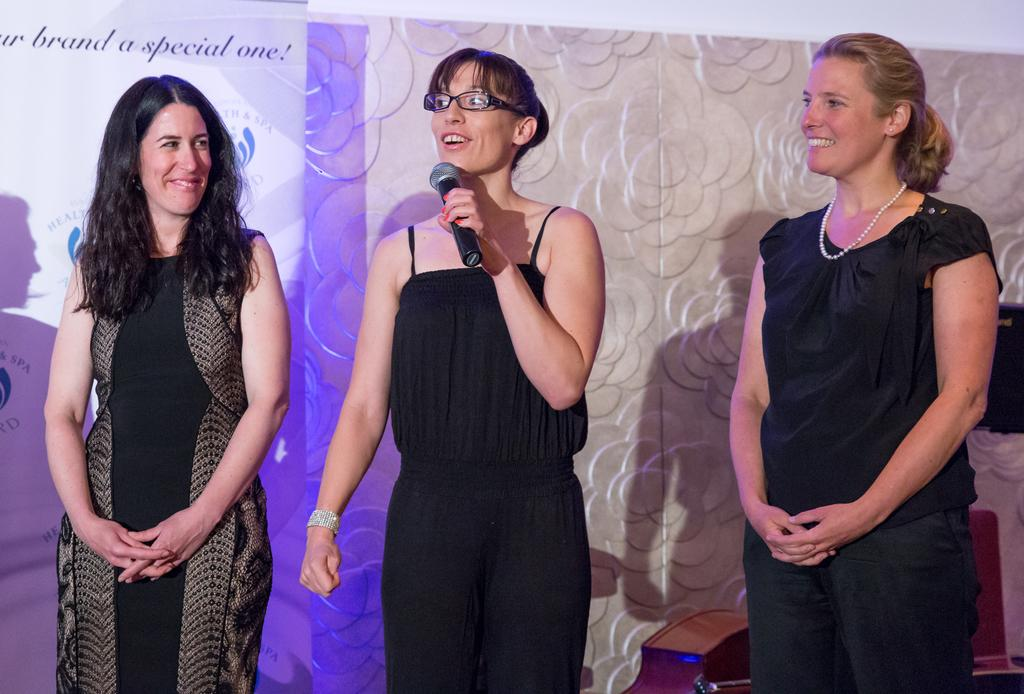How many women are present in the image? There are three women in the image. What is one of the women doing with her hand? One of the women is holding a mic in her hand. Can you describe the appearance of the woman holding the mic? The woman holding the mic is wearing spectacles. What can be seen on the wall in the background of the image? There is a banner on the wall in the background. Are there any beds visible in the image? No, there are no beds present in the image. Can you describe the type of butter being used by the women in the image? There is no butter present in the image, and the women are not using any butter. 